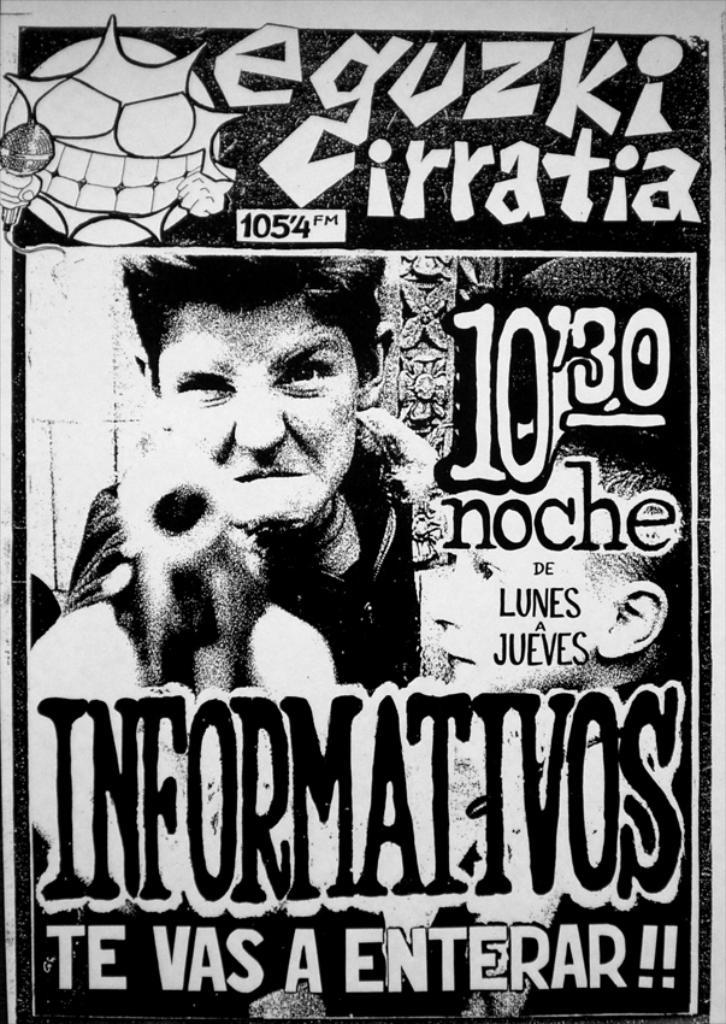<image>
Give a short and clear explanation of the subsequent image. A poster showing a man pointing a gun advertises 105.4 FM radio station. 